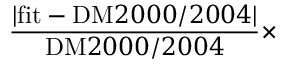Convert formula to latex. <formula><loc_0><loc_0><loc_500><loc_500>\frac { | f i t - D M 2 0 0 0 / 2 0 0 4 | } { D M 2 0 0 0 / 2 0 0 4 } \times</formula> 